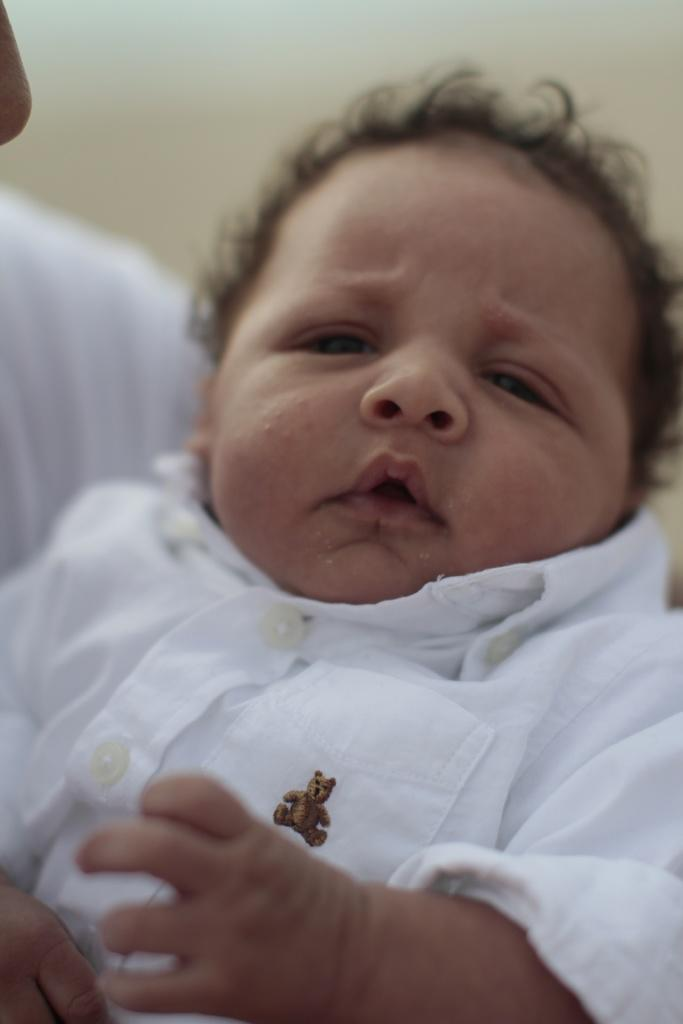What is the main subject of the image? The main subject of the image is a kid. What is the kid wearing in the image? The kid is wearing a white colored shirt in the image. Can you describe the person on the left side of the image? Unfortunately, the provided facts do not mention any details about the person on the left side of the image. What type of powder is being used by the pig in the image? There is no pig present in the image, so it is not possible to determine if any powder is being used. 